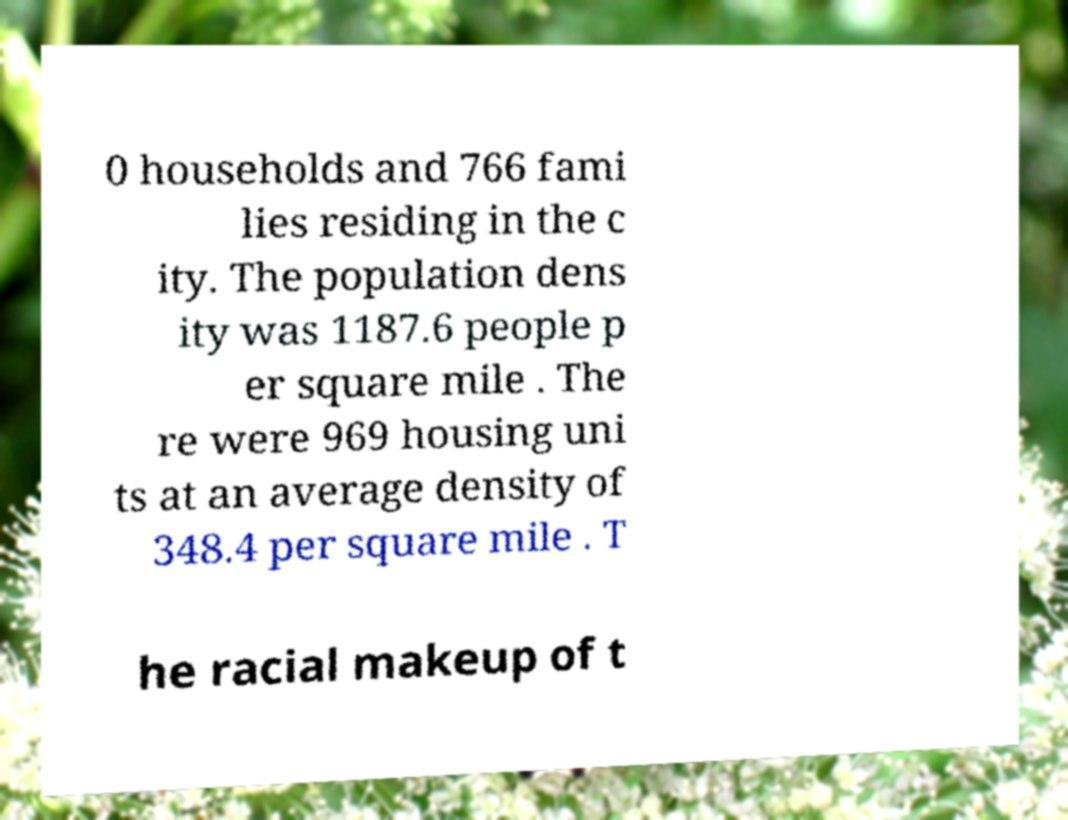Can you read and provide the text displayed in the image?This photo seems to have some interesting text. Can you extract and type it out for me? 0 households and 766 fami lies residing in the c ity. The population dens ity was 1187.6 people p er square mile . The re were 969 housing uni ts at an average density of 348.4 per square mile . T he racial makeup of t 